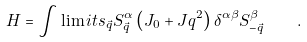Convert formula to latex. <formula><loc_0><loc_0><loc_500><loc_500>H = \int \lim i t s _ { \vec { q } } S _ { \vec { q } } ^ { \alpha } \left ( J _ { 0 } + J q ^ { 2 } \right ) \delta ^ { \alpha \beta } S _ { - { \vec { q } } } ^ { \beta } \quad .</formula> 